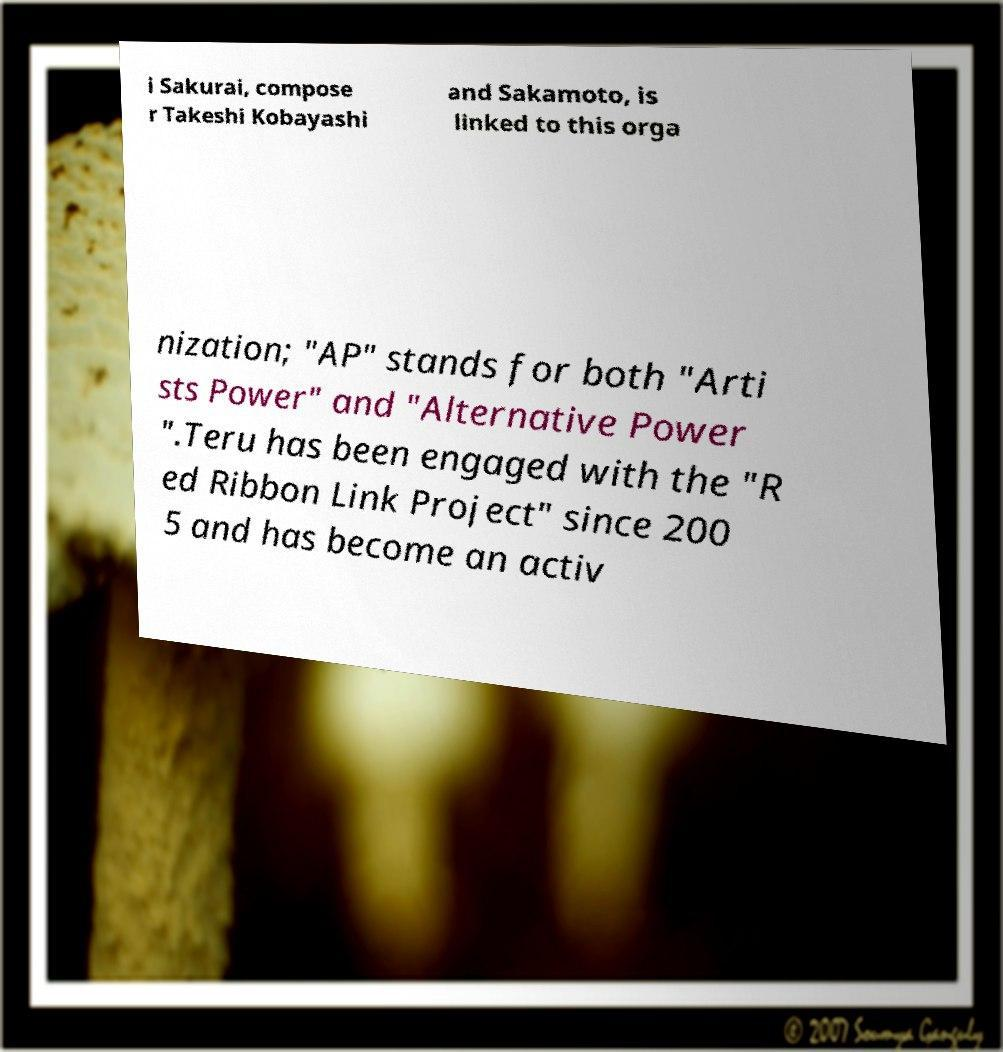I need the written content from this picture converted into text. Can you do that? i Sakurai, compose r Takeshi Kobayashi and Sakamoto, is linked to this orga nization; "AP" stands for both "Arti sts Power" and "Alternative Power ".Teru has been engaged with the "R ed Ribbon Link Project" since 200 5 and has become an activ 